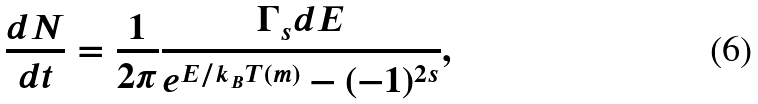Convert formula to latex. <formula><loc_0><loc_0><loc_500><loc_500>\frac { d N } { d t } = \frac { 1 } { 2 \pi } \frac { \Gamma _ { s } d E } { e ^ { E / k _ { B } T ( m ) } - ( - 1 ) ^ { 2 s } } ,</formula> 